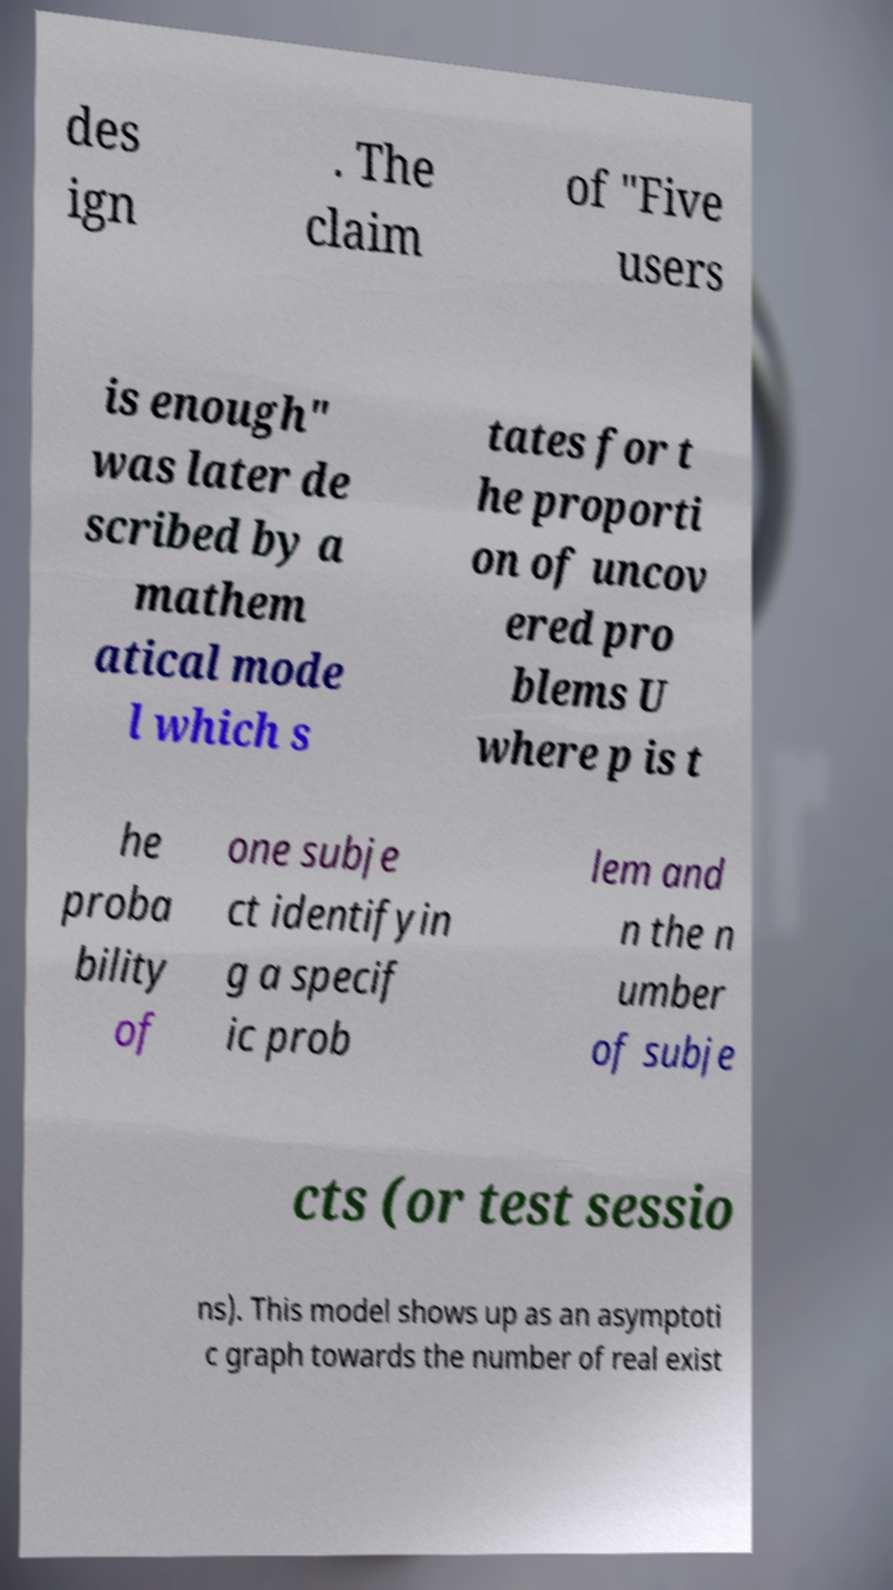There's text embedded in this image that I need extracted. Can you transcribe it verbatim? des ign . The claim of "Five users is enough" was later de scribed by a mathem atical mode l which s tates for t he proporti on of uncov ered pro blems U where p is t he proba bility of one subje ct identifyin g a specif ic prob lem and n the n umber of subje cts (or test sessio ns). This model shows up as an asymptoti c graph towards the number of real exist 